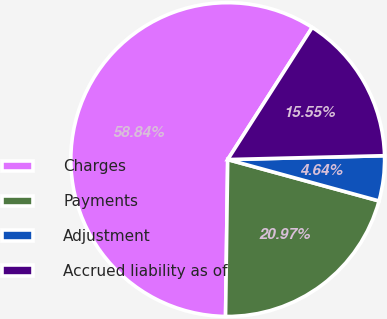Convert chart to OTSL. <chart><loc_0><loc_0><loc_500><loc_500><pie_chart><fcel>Charges<fcel>Payments<fcel>Adjustment<fcel>Accrued liability as of<nl><fcel>58.84%<fcel>20.97%<fcel>4.64%<fcel>15.55%<nl></chart> 